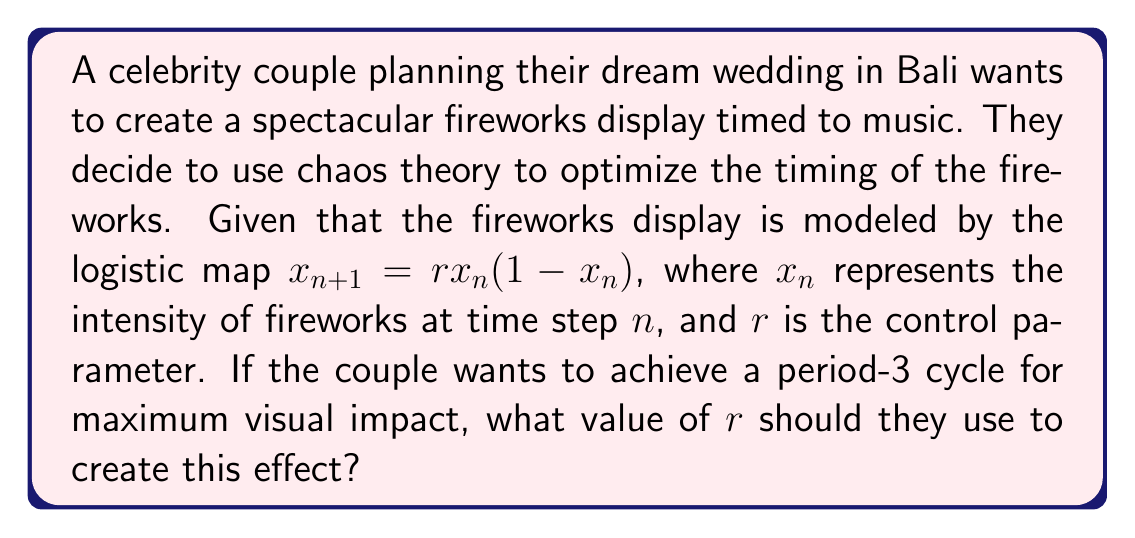Solve this math problem. To solve this problem, we need to follow these steps:

1) The logistic map is given by $x_{n+1} = rx_n(1-x_n)$

2) For a period-3 cycle, we need to find $r$ such that $x_{n+3} = x_n$

3) This means we need to solve the equation:
   $x = r^3x(1-x)(1-rx(1-x))(1-rx(1-rx(1-x)))$

4) Expanding this equation leads to a complex polynomial in $x$ and $r$

5) The smallest value of $r$ that allows for a period-3 cycle is the solution to the equation:
   $r^3 - 2r^2 - r - 1 = 0$

6) This equation can be solved numerically or using the cubic formula

7) The solution is approximately $r \approx 3.8284271247461903$

8) This value of $r$ is known as the onset of chaos for period-3 in the logistic map

9) At this value of $r$, the system will cycle through three different intensities, creating a visually appealing pattern for the fireworks display
Answer: $r \approx 3.8284271247461903$ 